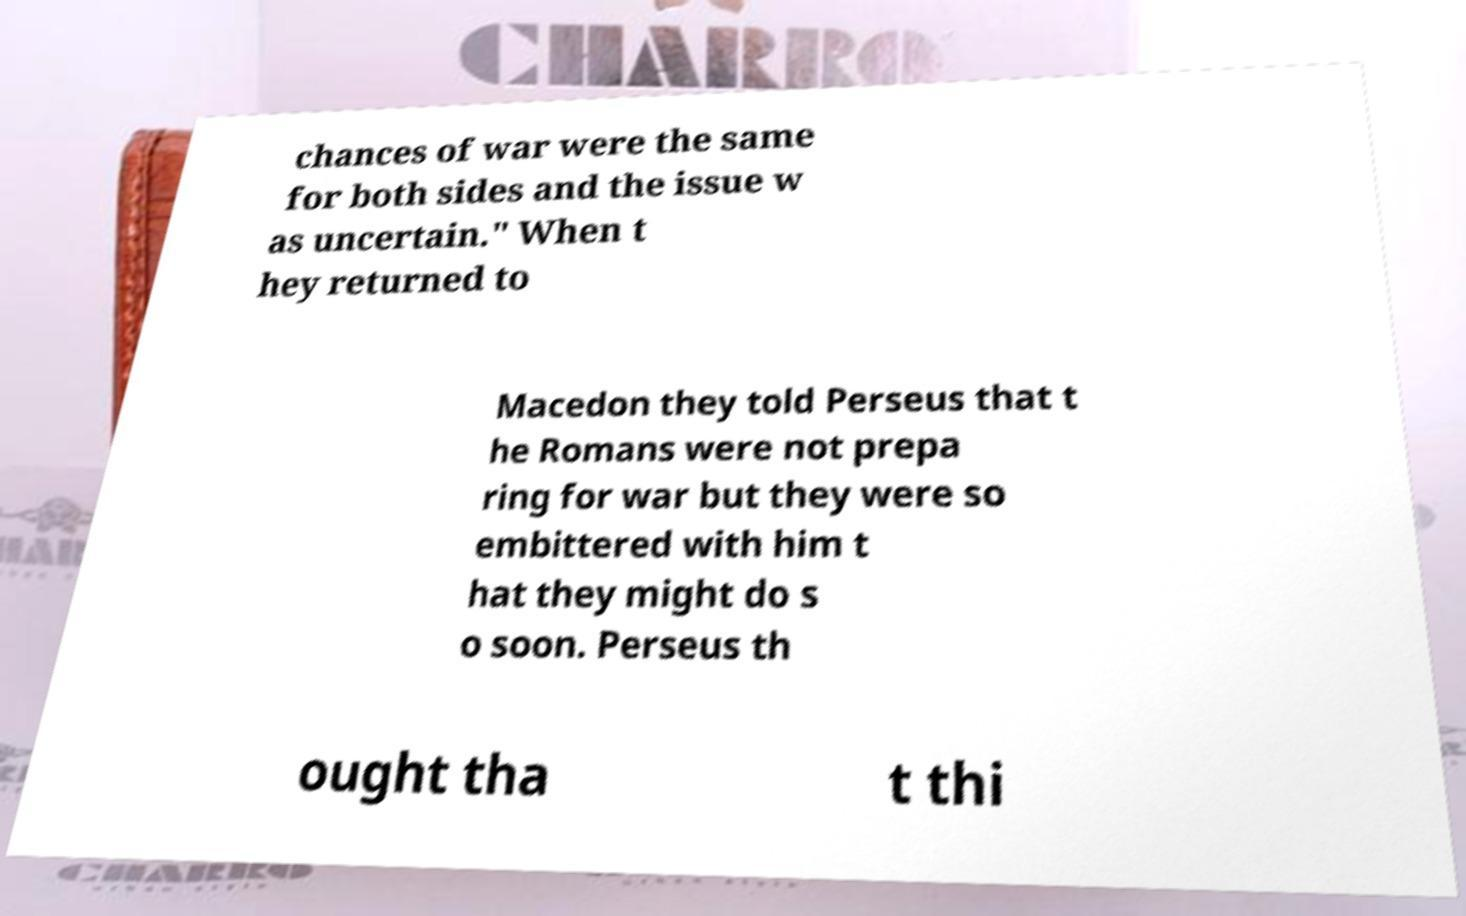Could you assist in decoding the text presented in this image and type it out clearly? chances of war were the same for both sides and the issue w as uncertain." When t hey returned to Macedon they told Perseus that t he Romans were not prepa ring for war but they were so embittered with him t hat they might do s o soon. Perseus th ought tha t thi 